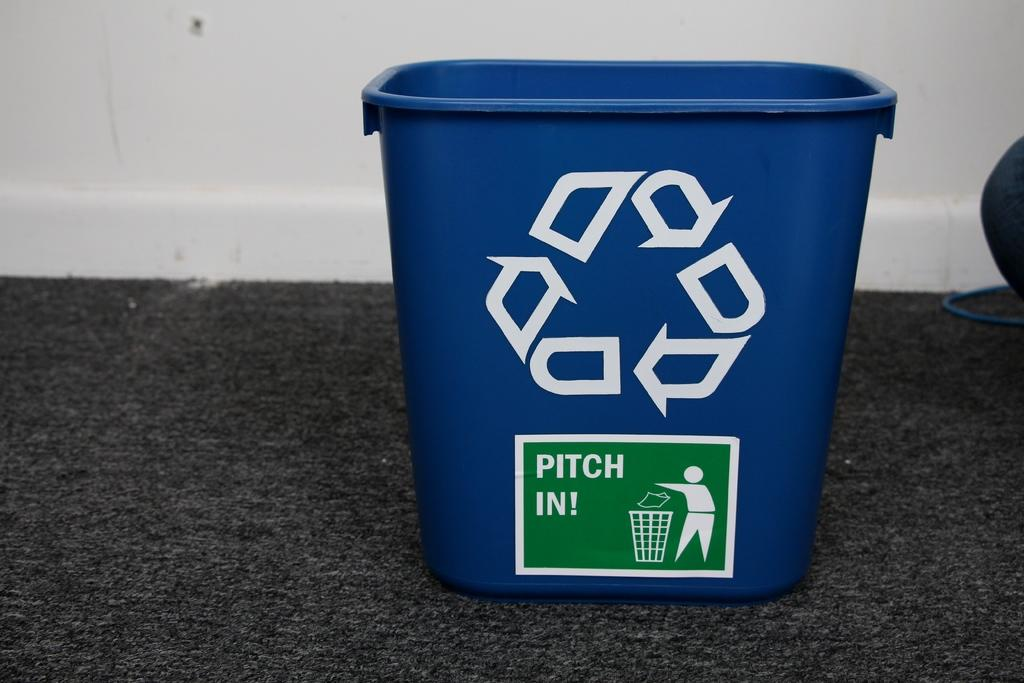<image>
Relay a brief, clear account of the picture shown. A blue recycling can that encourage you to pitch in. 